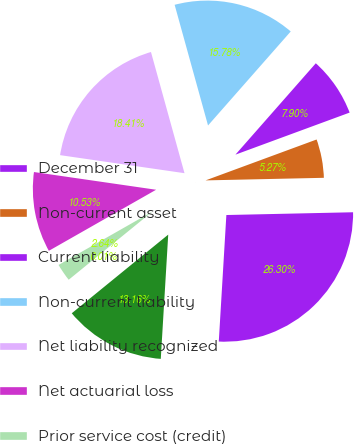<chart> <loc_0><loc_0><loc_500><loc_500><pie_chart><fcel>December 31<fcel>Non-current asset<fcel>Current liability<fcel>Non-current liability<fcel>Net liability recognized<fcel>Net actuarial loss<fcel>Prior service cost (credit)<fcel>Transition obligation<fcel>Total amount recognized<nl><fcel>26.3%<fcel>5.27%<fcel>7.9%<fcel>15.78%<fcel>18.41%<fcel>10.53%<fcel>2.64%<fcel>0.01%<fcel>13.16%<nl></chart> 